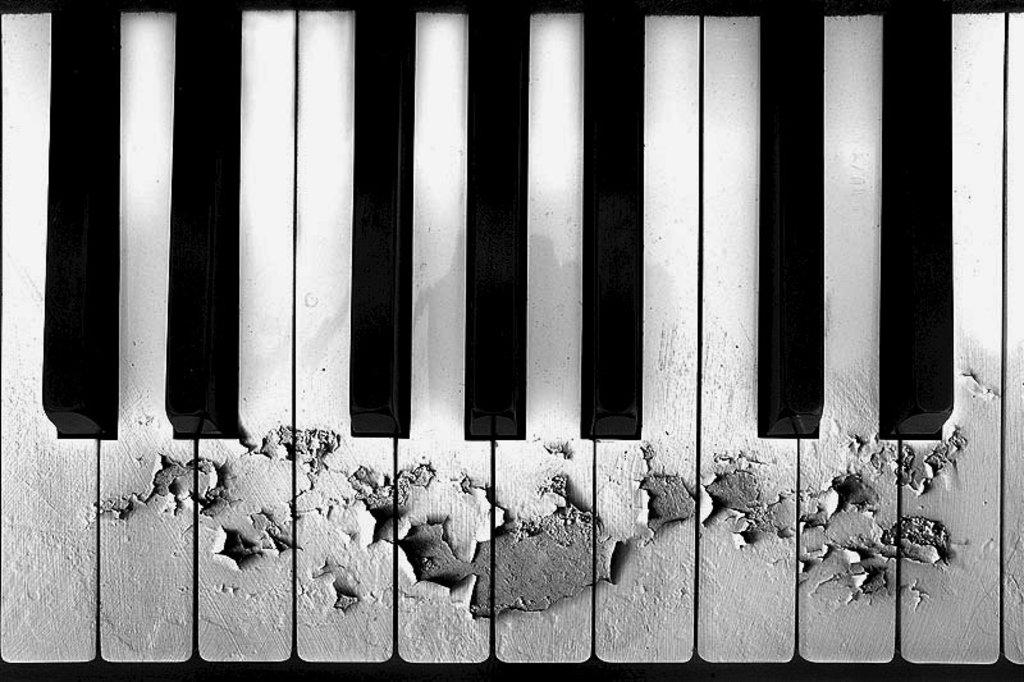What is the main object in the image? There is a piano keyboard in the image. What can be observed about the keys on the piano keyboard? The piano keyboard has black and white keys. What material is the piano keyboard made of? The piano keyboard is made of wood. Are there any noticeable modifications to the wooden structure? Yes, some parts of the wooden structure are removed. What type of twist can be seen in the image? There is no twist present in the image. 